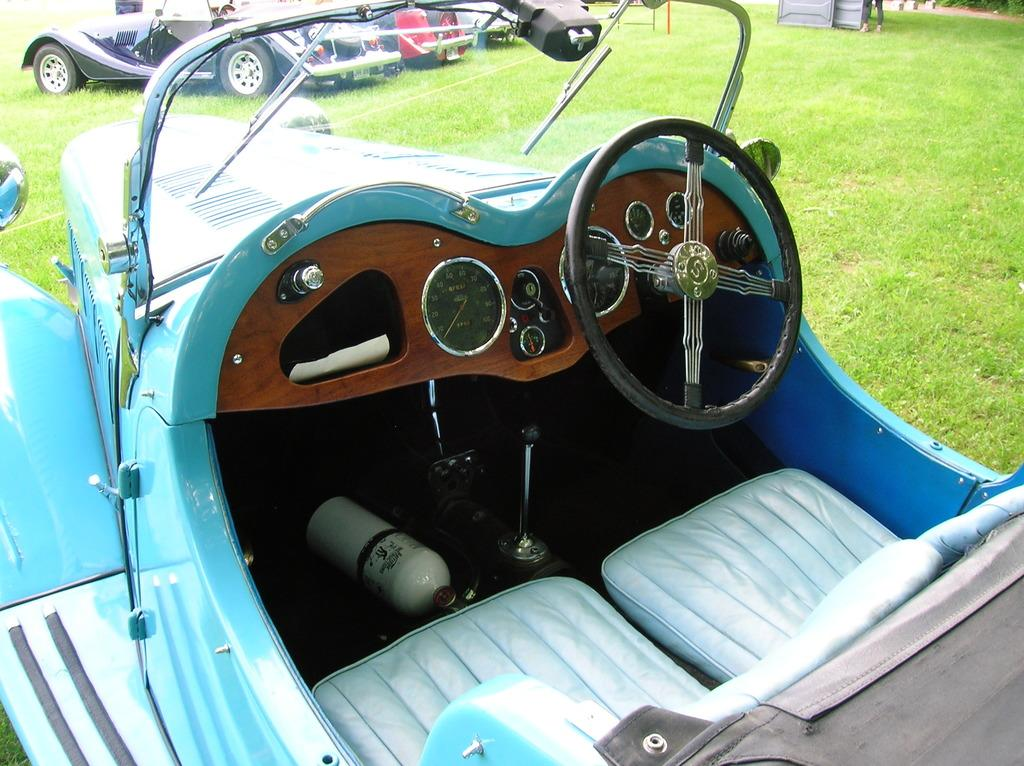What type of objects are present in the image? There are vehicles in the image. What features are present in the vehicles? The vehicles have seats, a steering part, and a speedometer. What can be seen in the background of the image? There is grass visible in the image. Is there a person in the image? Yes, there is a person standing in the image. What type of bear can be seen interacting with the person in the image? There is no bear present in the image; it only features vehicles, grass, and a person standing. What beast is responsible for the speedometer's functionality in the image? The speedometer's functionality is not related to any beast; it is an electronic device in the vehicles. 